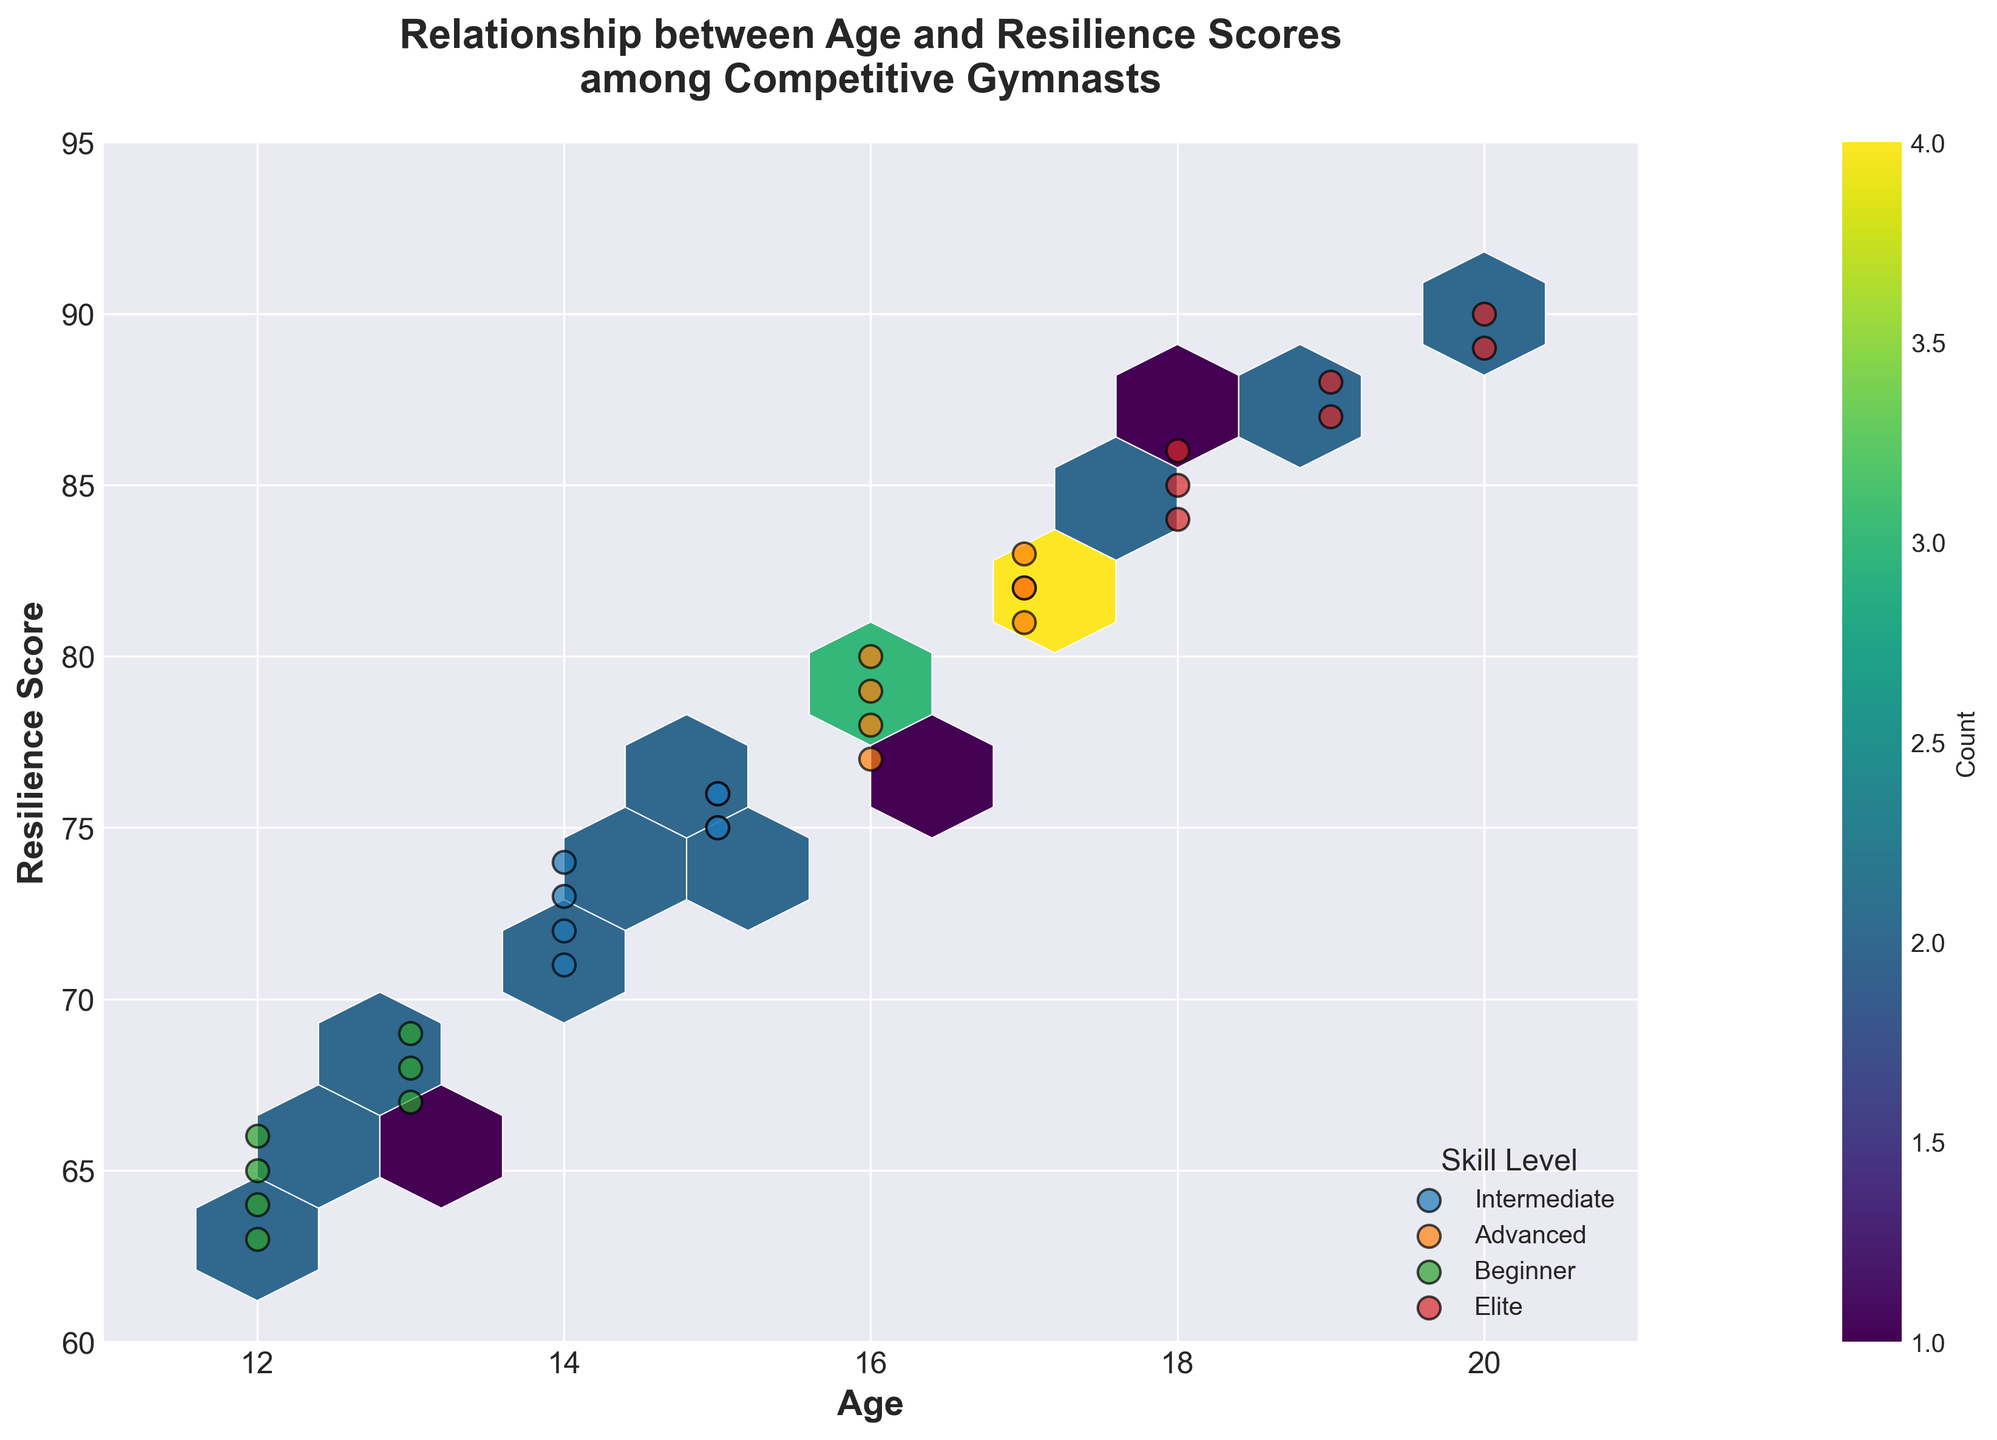What is the title of the plot? The title can be found at the top of the plot. It reads: "Relationship between Age and Resilience Scores among Competitive Gymnasts".
Answer: Relationship between Age and Resilience Scores among Competitive Gymnasts What are the axes labels for this hexbin plot? The x-axis and y-axis labels are provided just next to the axes. The x-axis is labeled as "Age", and the y-axis is labeled as "Resilience Score".
Answer: Age and Resilience Score What age range is covered in the plot? By looking at the x-axis, the ages range from the minimum value, which is around 12, to the maximum, which is around 20.
Answer: 12 to 20 What is the range of resilience scores displayed on the plot? By examining the y-axis, the resilience scores range from the minimum value of around 60 to the maximum of around 95.
Answer: 60 to 95 How many hexagonal bins are used in the plot? The number of hexagonal bins can be inferred from the grid appearance. By closely inspecting the density of the hexagons, one can see there are multiple bins distributed across the plot. However, without exact numbers, one can generally approximate the bins from the grid size input parameter, which is 10.
Answer: 10 Which skill level has the highest resilience scores? By examining the points plotted on the higher end of the resilience score (near 90), "Elite" skill level shows the highest resilience scores.
Answer: Elite Are there more intermediate gymnasts aged 15 or 16? To determine this, look at the density of the hexbin around ages 15 and 16 with the label "Intermediate" color. There are more markers around 15 than 16.
Answer: 15 What skill levels do gymnasts aged 12 belong to? Look for the points at age 12, and note their associated skill levels which are color-coded. These belong to "Beginner".
Answer: Beginner Which age group appears to have the most diverse range of resilience scores? To find this, look for the age group with the widest vertical spread of points. Ages around 16-17 have a broader range of resilience scores from approximately mid-70s to over 80s.
Answer: 16-17 Are resilience scores for gymnasts aged 14 more concentrated or diverse? By observing the concentration of points at age 14, we see that they are quite clustered around the mid-70s range, suggesting more concentration.
Answer: Concentrated 